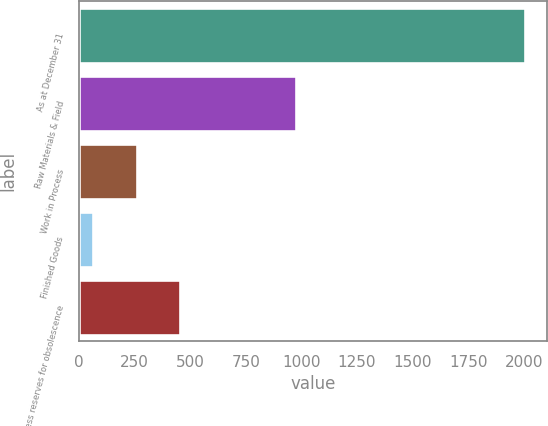<chart> <loc_0><loc_0><loc_500><loc_500><bar_chart><fcel>As at December 31<fcel>Raw Materials & Field<fcel>Work in Process<fcel>Finished Goods<fcel>Less reserves for obsolescence<nl><fcel>2005<fcel>976<fcel>259<fcel>65<fcel>453<nl></chart> 